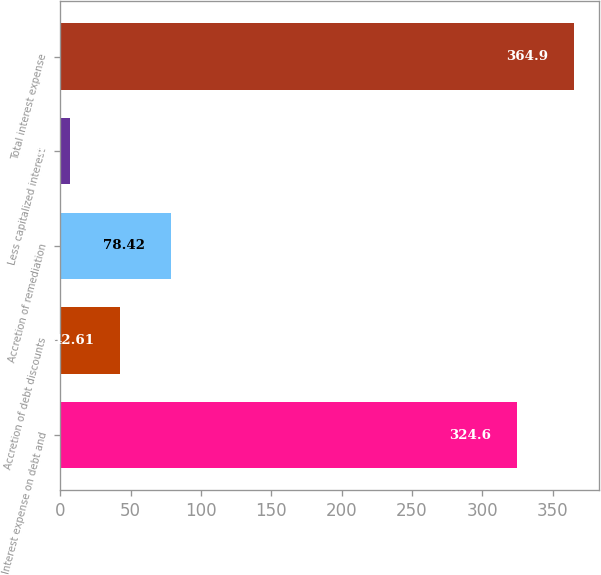Convert chart. <chart><loc_0><loc_0><loc_500><loc_500><bar_chart><fcel>Interest expense on debt and<fcel>Accretion of debt discounts<fcel>Accretion of remediation<fcel>Less capitalized interest<fcel>Total interest expense<nl><fcel>324.6<fcel>42.61<fcel>78.42<fcel>6.8<fcel>364.9<nl></chart> 